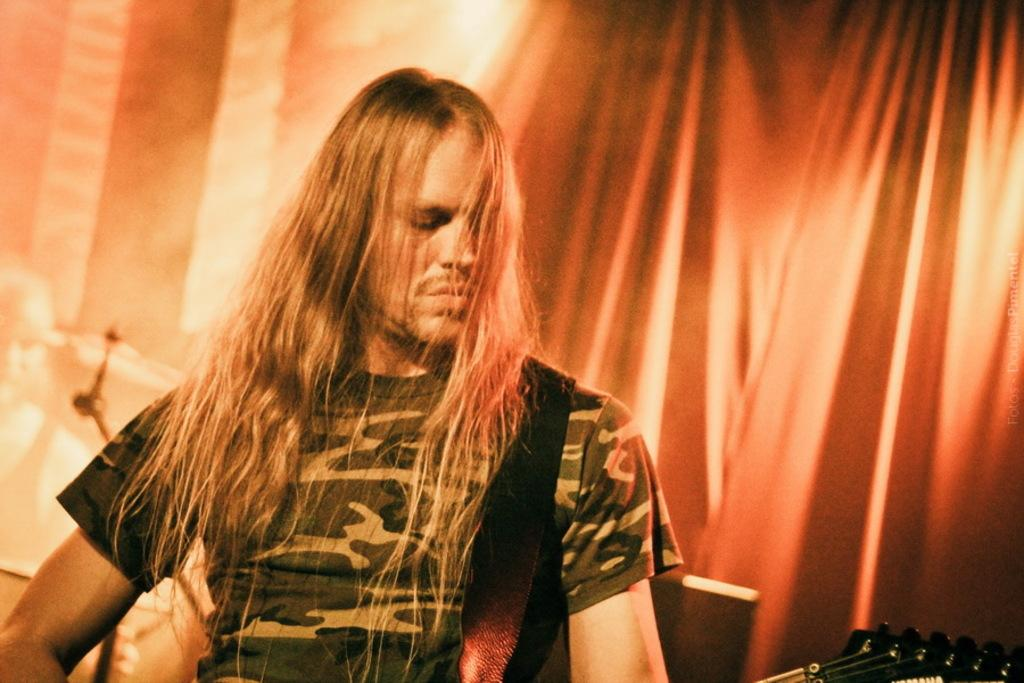Who is present in the image? There is a man in the image. What is the man holding in the image? The man is holding a musical instrument. What can be seen in the background of the image? There is a curtain in the background of the image. What type of soup is the man eating in the image? There is no soup present in the image; the man is holding a musical instrument. 